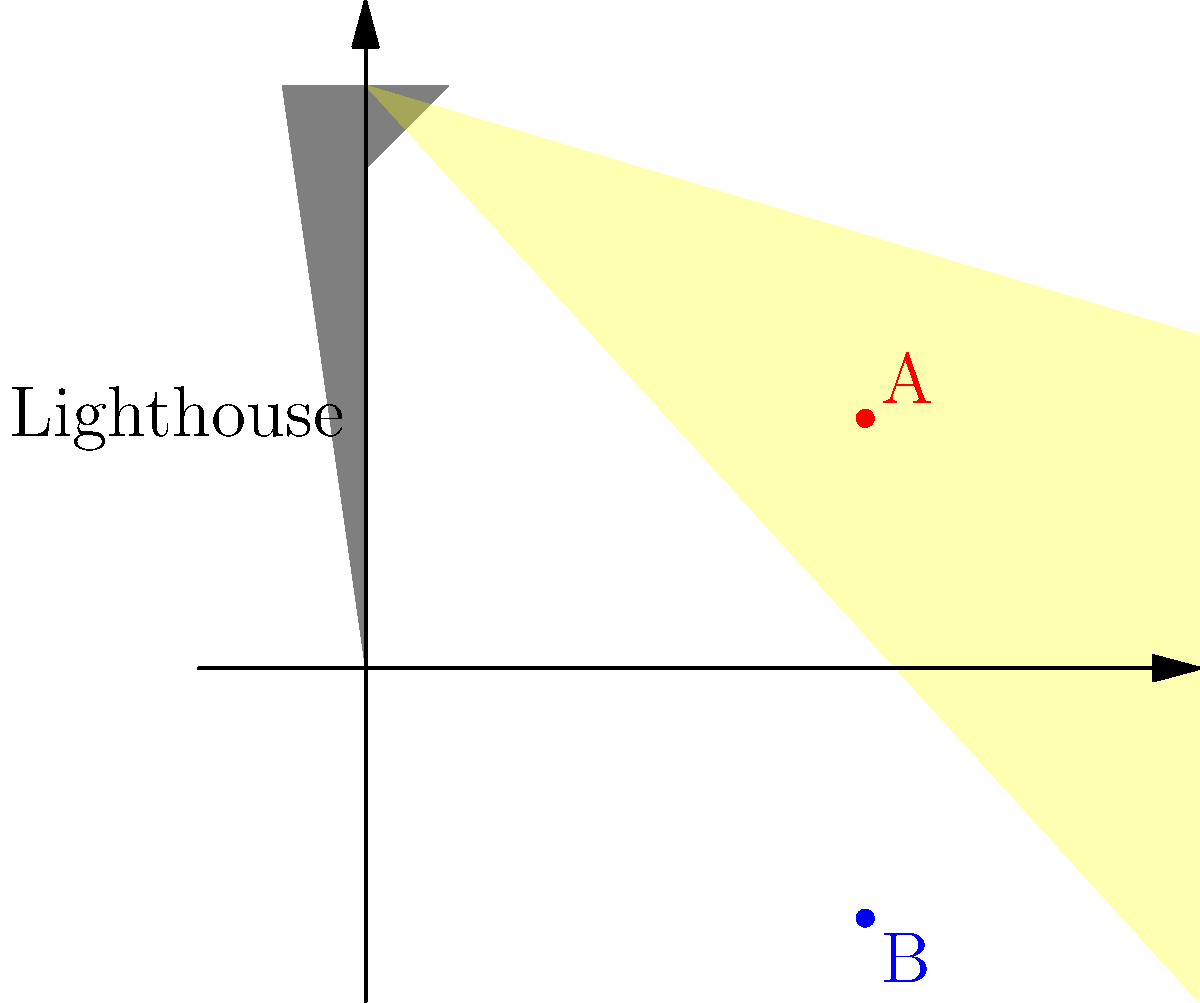A lighthouse beam rotates clockwise when viewed from above. If an observer at point A sees the beam pass at a certain moment, how long will it take for an observer at point B to see the beam, assuming the beam completes one full rotation every 10 seconds? To solve this problem, we need to follow these steps:

1. Understand the rotation: The beam rotates clockwise when viewed from above.

2. Analyze the positions: 
   - Point A is above the horizontal axis
   - Point B is below the horizontal axis

3. Determine the rotation angle:
   - The beam needs to rotate from A to B
   - This is a quarter (1/4) of a full rotation

4. Calculate the time:
   - One full rotation takes 10 seconds
   - A quarter rotation is 1/4 of 10 seconds
   - Time = $\frac{1}{4} \times 10 = 2.5$ seconds

Therefore, it will take 2.5 seconds for the observer at point B to see the beam after the observer at point A sees it.
Answer: 2.5 seconds 